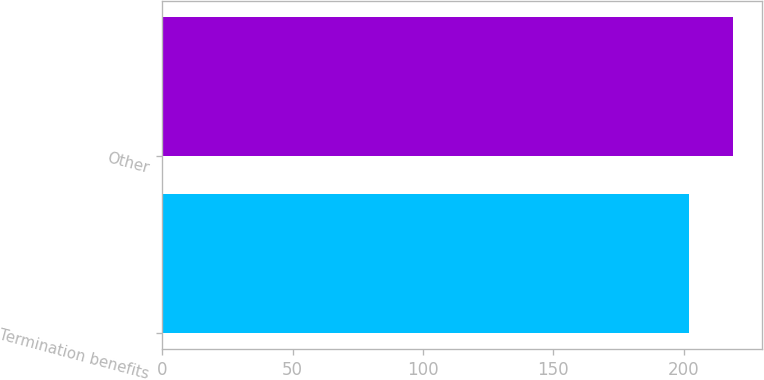Convert chart. <chart><loc_0><loc_0><loc_500><loc_500><bar_chart><fcel>Termination benefits<fcel>Other<nl><fcel>202<fcel>219<nl></chart> 